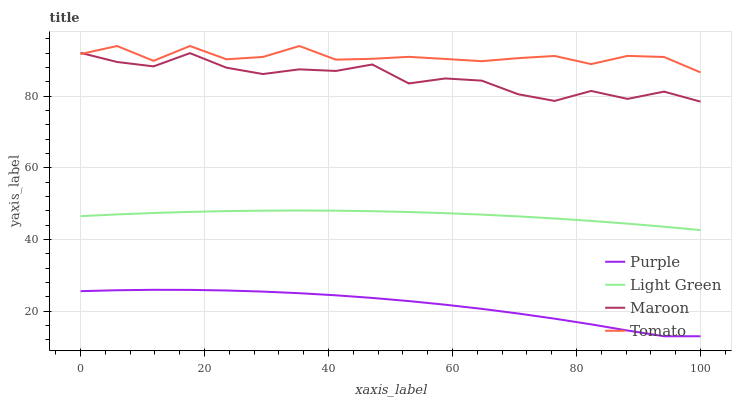Does Purple have the minimum area under the curve?
Answer yes or no. Yes. Does Tomato have the maximum area under the curve?
Answer yes or no. Yes. Does Maroon have the minimum area under the curve?
Answer yes or no. No. Does Maroon have the maximum area under the curve?
Answer yes or no. No. Is Light Green the smoothest?
Answer yes or no. Yes. Is Maroon the roughest?
Answer yes or no. Yes. Is Tomato the smoothest?
Answer yes or no. No. Is Tomato the roughest?
Answer yes or no. No. Does Purple have the lowest value?
Answer yes or no. Yes. Does Maroon have the lowest value?
Answer yes or no. No. Does Tomato have the highest value?
Answer yes or no. Yes. Does Maroon have the highest value?
Answer yes or no. No. Is Purple less than Tomato?
Answer yes or no. Yes. Is Light Green greater than Purple?
Answer yes or no. Yes. Does Maroon intersect Tomato?
Answer yes or no. Yes. Is Maroon less than Tomato?
Answer yes or no. No. Is Maroon greater than Tomato?
Answer yes or no. No. Does Purple intersect Tomato?
Answer yes or no. No. 